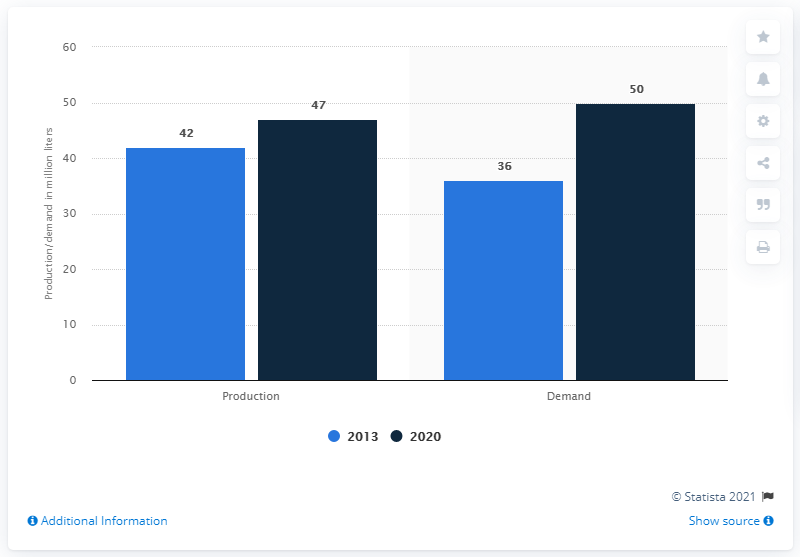Indicate a few pertinent items in this graphic. In 2013, the global demand for plasma was approximately 36 million units. By 2020, it is projected that there will be a significant increase in plasma demand. 